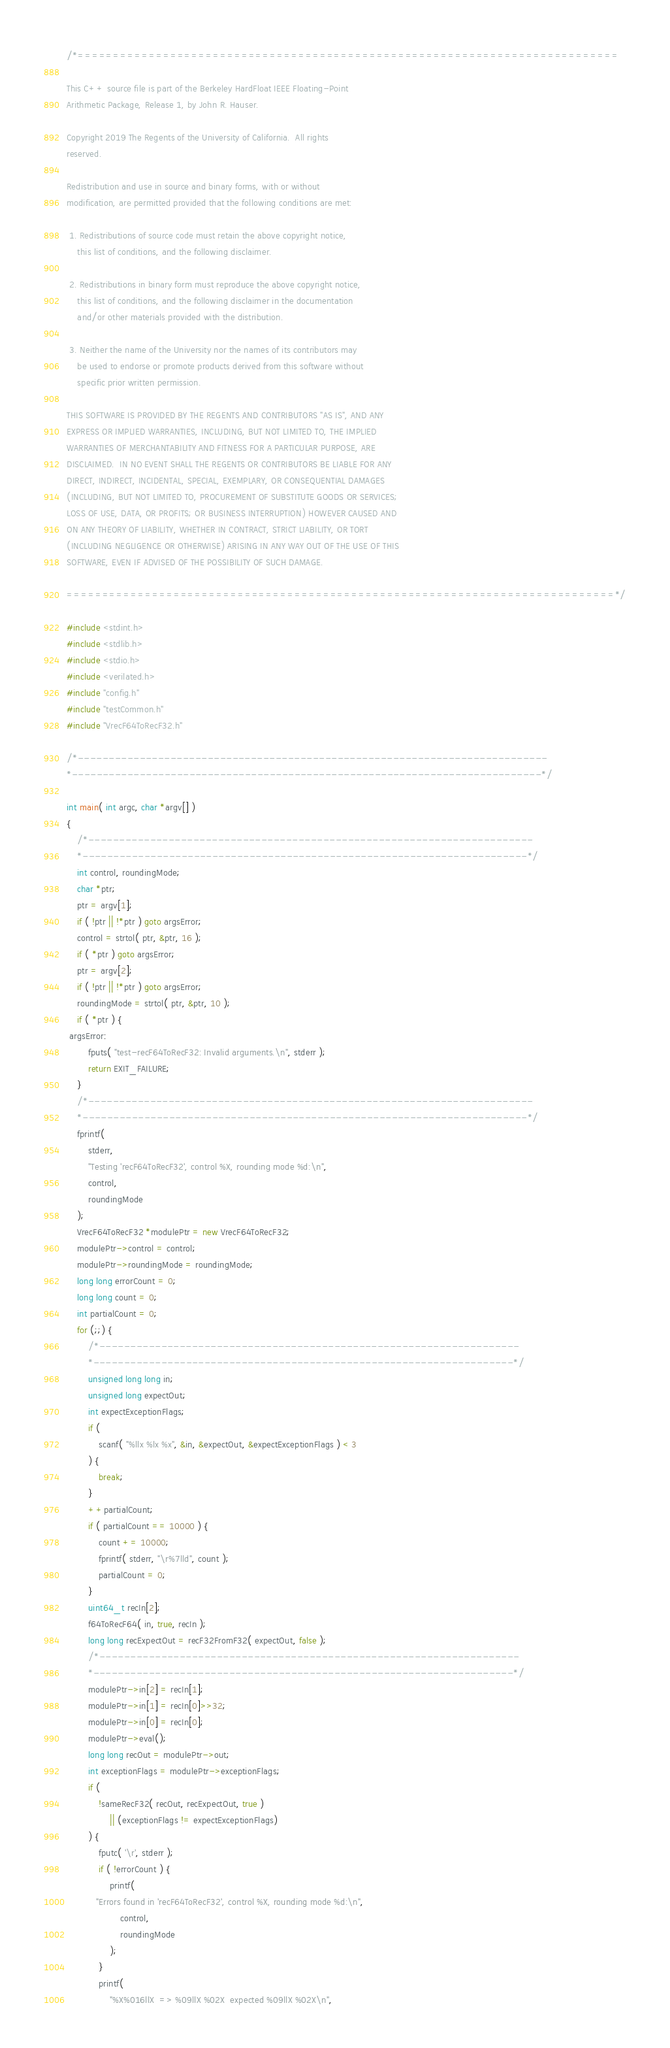<code> <loc_0><loc_0><loc_500><loc_500><_C++_>
/*============================================================================

This C++ source file is part of the Berkeley HardFloat IEEE Floating-Point
Arithmetic Package, Release 1, by John R. Hauser.

Copyright 2019 The Regents of the University of California.  All rights
reserved.

Redistribution and use in source and binary forms, with or without
modification, are permitted provided that the following conditions are met:

 1. Redistributions of source code must retain the above copyright notice,
    this list of conditions, and the following disclaimer.

 2. Redistributions in binary form must reproduce the above copyright notice,
    this list of conditions, and the following disclaimer in the documentation
    and/or other materials provided with the distribution.

 3. Neither the name of the University nor the names of its contributors may
    be used to endorse or promote products derived from this software without
    specific prior written permission.

THIS SOFTWARE IS PROVIDED BY THE REGENTS AND CONTRIBUTORS "AS IS", AND ANY
EXPRESS OR IMPLIED WARRANTIES, INCLUDING, BUT NOT LIMITED TO, THE IMPLIED
WARRANTIES OF MERCHANTABILITY AND FITNESS FOR A PARTICULAR PURPOSE, ARE
DISCLAIMED.  IN NO EVENT SHALL THE REGENTS OR CONTRIBUTORS BE LIABLE FOR ANY
DIRECT, INDIRECT, INCIDENTAL, SPECIAL, EXEMPLARY, OR CONSEQUENTIAL DAMAGES
(INCLUDING, BUT NOT LIMITED TO, PROCUREMENT OF SUBSTITUTE GOODS OR SERVICES;
LOSS OF USE, DATA, OR PROFITS; OR BUSINESS INTERRUPTION) HOWEVER CAUSED AND
ON ANY THEORY OF LIABILITY, WHETHER IN CONTRACT, STRICT LIABILITY, OR TORT
(INCLUDING NEGLIGENCE OR OTHERWISE) ARISING IN ANY WAY OUT OF THE USE OF THIS
SOFTWARE, EVEN IF ADVISED OF THE POSSIBILITY OF SUCH DAMAGE.

=============================================================================*/

#include <stdint.h>
#include <stdlib.h>
#include <stdio.h>
#include <verilated.h>
#include "config.h"
#include "testCommon.h"
#include "VrecF64ToRecF32.h"

/*----------------------------------------------------------------------------
*----------------------------------------------------------------------------*/

int main( int argc, char *argv[] )
{
    /*------------------------------------------------------------------------
    *------------------------------------------------------------------------*/
    int control, roundingMode;
    char *ptr;
    ptr = argv[1];
    if ( !ptr || !*ptr ) goto argsError;
    control = strtol( ptr, &ptr, 16 );
    if ( *ptr ) goto argsError;
    ptr = argv[2];
    if ( !ptr || !*ptr ) goto argsError;
    roundingMode = strtol( ptr, &ptr, 10 );
    if ( *ptr ) {
 argsError:
        fputs( "test-recF64ToRecF32: Invalid arguments.\n", stderr );
        return EXIT_FAILURE;
    }
    /*------------------------------------------------------------------------
    *------------------------------------------------------------------------*/
    fprintf(
        stderr,
        "Testing 'recF64ToRecF32', control %X, rounding mode %d:\n",
        control,
        roundingMode
    );
    VrecF64ToRecF32 *modulePtr = new VrecF64ToRecF32;
    modulePtr->control = control;
    modulePtr->roundingMode = roundingMode;
    long long errorCount = 0;
    long long count = 0;
    int partialCount = 0;
    for (;;) {
        /*--------------------------------------------------------------------
        *--------------------------------------------------------------------*/
        unsigned long long in;
        unsigned long expectOut;
        int expectExceptionFlags;
        if (
            scanf( "%llx %lx %x", &in, &expectOut, &expectExceptionFlags ) < 3
        ) {
            break;
        }
        ++partialCount;
        if ( partialCount == 10000 ) {
            count += 10000;
            fprintf( stderr, "\r%7lld", count );
            partialCount = 0;
        }
        uint64_t recIn[2];
        f64ToRecF64( in, true, recIn );
        long long recExpectOut = recF32FromF32( expectOut, false );
        /*--------------------------------------------------------------------
        *--------------------------------------------------------------------*/
        modulePtr->in[2] = recIn[1];
        modulePtr->in[1] = recIn[0]>>32;
        modulePtr->in[0] = recIn[0];
        modulePtr->eval();
        long long recOut = modulePtr->out;
        int exceptionFlags = modulePtr->exceptionFlags;
        if (
            !sameRecF32( recOut, recExpectOut, true )
                || (exceptionFlags != expectExceptionFlags)
        ) {
            fputc( '\r', stderr );
            if ( !errorCount ) {
                printf(
           "Errors found in 'recF64ToRecF32', control %X, rounding mode %d:\n",
                    control,
                    roundingMode
                );
            }
            printf(
                "%X%016llX  => %09llX %02X  expected %09llX %02X\n",</code> 